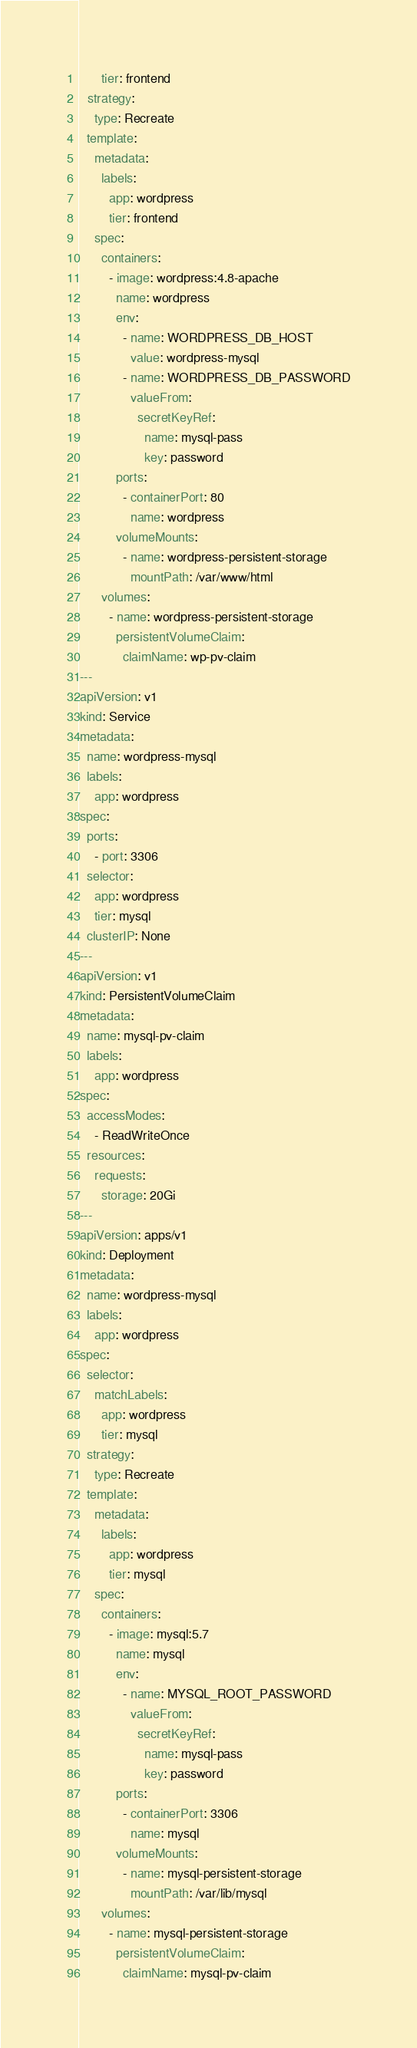<code> <loc_0><loc_0><loc_500><loc_500><_YAML_>      tier: frontend
  strategy:
    type: Recreate
  template:
    metadata:
      labels:
        app: wordpress
        tier: frontend
    spec:
      containers:
        - image: wordpress:4.8-apache
          name: wordpress
          env:
            - name: WORDPRESS_DB_HOST
              value: wordpress-mysql
            - name: WORDPRESS_DB_PASSWORD
              valueFrom:
                secretKeyRef:
                  name: mysql-pass
                  key: password
          ports:
            - containerPort: 80
              name: wordpress
          volumeMounts:
            - name: wordpress-persistent-storage
              mountPath: /var/www/html
      volumes:
        - name: wordpress-persistent-storage
          persistentVolumeClaim:
            claimName: wp-pv-claim
---
apiVersion: v1
kind: Service
metadata:
  name: wordpress-mysql
  labels:
    app: wordpress
spec:
  ports:
    - port: 3306
  selector:
    app: wordpress
    tier: mysql
  clusterIP: None
---
apiVersion: v1
kind: PersistentVolumeClaim
metadata:
  name: mysql-pv-claim
  labels:
    app: wordpress
spec:
  accessModes:
    - ReadWriteOnce
  resources:
    requests:
      storage: 20Gi
---
apiVersion: apps/v1
kind: Deployment
metadata:
  name: wordpress-mysql
  labels:
    app: wordpress
spec:
  selector:
    matchLabels:
      app: wordpress
      tier: mysql
  strategy:
    type: Recreate
  template:
    metadata:
      labels:
        app: wordpress
        tier: mysql
    spec:
      containers:
        - image: mysql:5.7
          name: mysql
          env:
            - name: MYSQL_ROOT_PASSWORD
              valueFrom:
                secretKeyRef:
                  name: mysql-pass
                  key: password
          ports:
            - containerPort: 3306
              name: mysql
          volumeMounts:
            - name: mysql-persistent-storage
              mountPath: /var/lib/mysql
      volumes:
        - name: mysql-persistent-storage
          persistentVolumeClaim:
            claimName: mysql-pv-claim</code> 